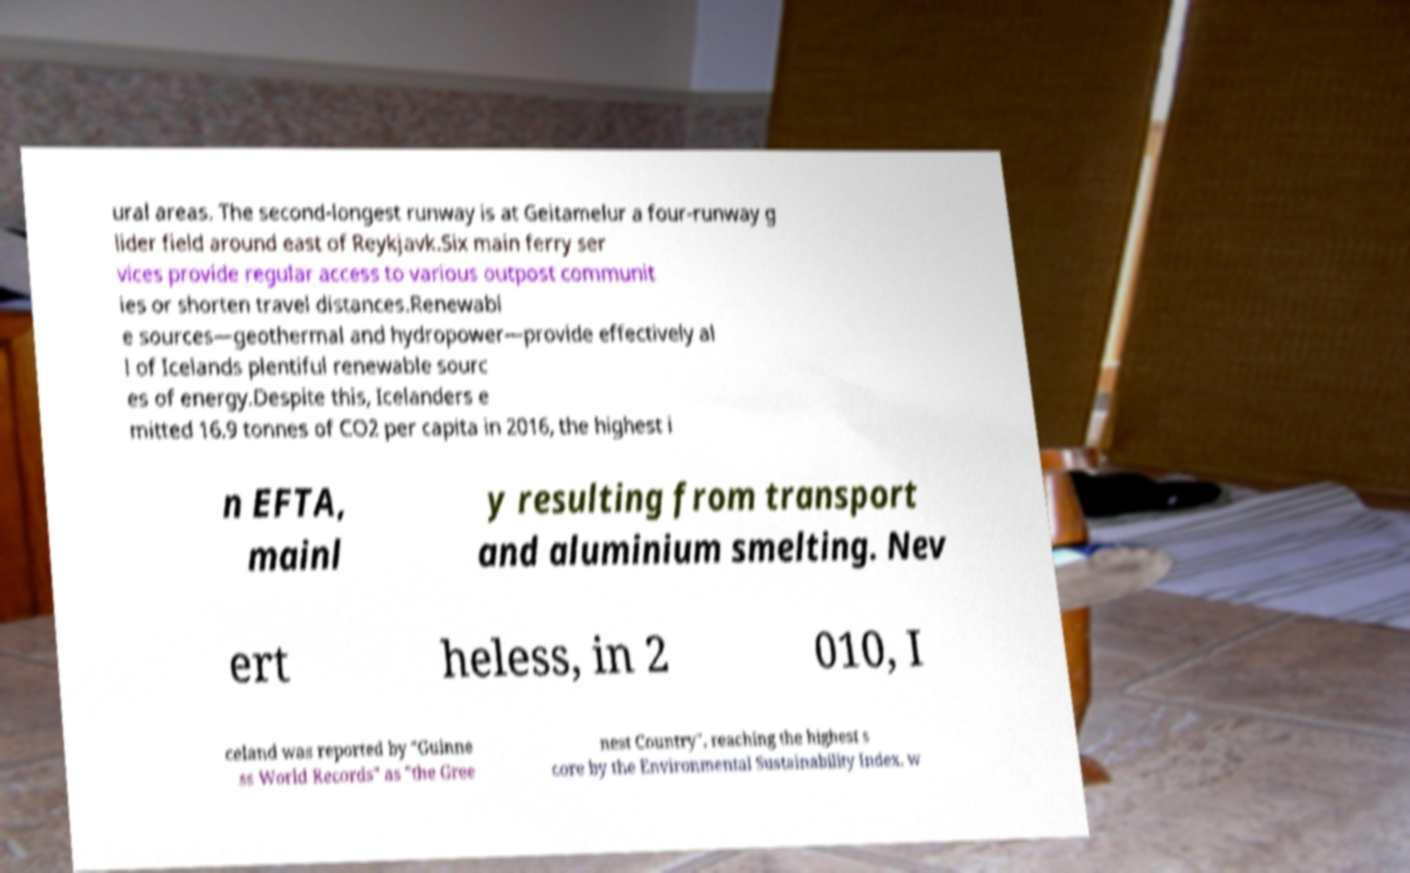Could you assist in decoding the text presented in this image and type it out clearly? ural areas. The second-longest runway is at Geitamelur a four-runway g lider field around east of Reykjavk.Six main ferry ser vices provide regular access to various outpost communit ies or shorten travel distances.Renewabl e sources—geothermal and hydropower—provide effectively al l of Icelands plentiful renewable sourc es of energy.Despite this, Icelanders e mitted 16.9 tonnes of CO2 per capita in 2016, the highest i n EFTA, mainl y resulting from transport and aluminium smelting. Nev ert heless, in 2 010, I celand was reported by "Guinne ss World Records" as "the Gree nest Country", reaching the highest s core by the Environmental Sustainability Index, w 